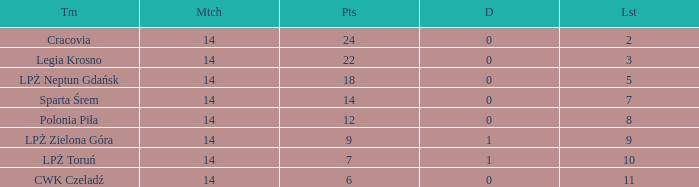Would you be able to parse every entry in this table? {'header': ['Tm', 'Mtch', 'Pts', 'D', 'Lst'], 'rows': [['Cracovia', '14', '24', '0', '2'], ['Legia Krosno', '14', '22', '0', '3'], ['LPŻ Neptun Gdańsk', '14', '18', '0', '5'], ['Sparta Śrem', '14', '14', '0', '7'], ['Polonia Piła', '14', '12', '0', '8'], ['LPŻ Zielona Góra', '14', '9', '1', '9'], ['LPŻ Toruń', '14', '7', '1', '10'], ['CWK Czeladź', '14', '6', '0', '11']]} What is the highest loss with points less than 7? 11.0. 